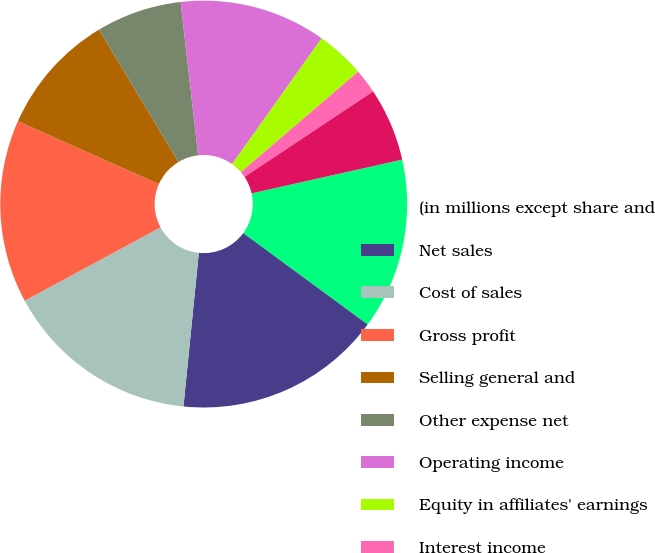Convert chart to OTSL. <chart><loc_0><loc_0><loc_500><loc_500><pie_chart><fcel>(in millions except share and<fcel>Net sales<fcel>Cost of sales<fcel>Gross profit<fcel>Selling general and<fcel>Other expense net<fcel>Operating income<fcel>Equity in affiliates' earnings<fcel>Interest income<fcel>Interest expense and finance<nl><fcel>13.59%<fcel>16.5%<fcel>15.53%<fcel>14.56%<fcel>9.71%<fcel>6.8%<fcel>11.65%<fcel>3.88%<fcel>1.94%<fcel>5.83%<nl></chart> 